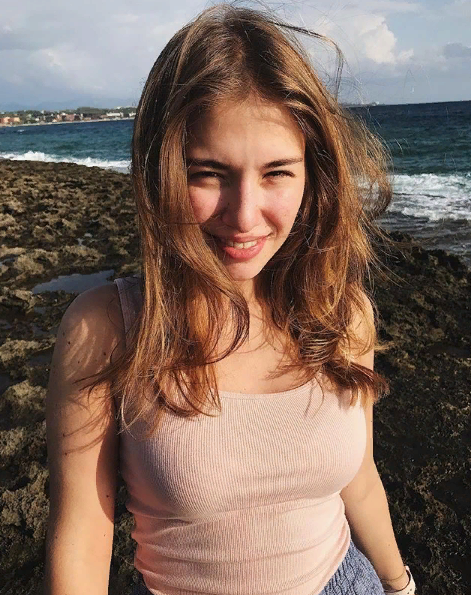Какие 3 участника корейской группы - BTS нравятся(близки) девушке на фото? Кто ей нравится больше по внешности(красоте лице, красоте глаз) из всех 7 участников BTS? Какие глаза(разрез, форма, тип) каждого участника нравятся моей девушке на фото в процентном соотношении? Кто ей нравится по голосу(вокалу, тембру) - из каждого участников BTS в процентном соотношении? На какие 52 народа(национальностей) похожа внешне(визуально) девушка на фото? На какие 7 типов европеоидной расы и  7 типов монголоидной расы похожа моя девушка на фото? Оцени её красоту и 100-бальной и 10-бальной шкале. Насколько красивое лицо у моей девушки на фото? Какие самые красивые у неё черты лица(глаза, губы, брови, нос, уши)? Участники корейской группы BTS, которые нравятся девушке на фото, - это Ви, Шуга и Чонгук. Из всех участников BTS ей больше всего нравится Ви по внешности (красоте лица, красоте глаз).

Глаза Ви (разрез, форма, тип) нравятся девушке на фото на 100%. Глаза Шуги нравятся ей на 90%, а глаза Чонгука - на 80%.

По голосу (вокалу, тембру) девушке на фото больше всего нравится Ви - на 100%. Шуга нравится ей на 90%, а Чонгук - на 80%.

Внешне (визуально) девушка на фото похожа на 52 народа (национальности). Она похожа на русские, украинки, белоруски, полячки, чешки, словачки, немки, австрийки, швейцарки, француженки, итальянки, испанки, португалки, румынки, венгерки, словенки, хорватки, сербки, боснийки, черногорки, македонки, болгарки, гречанки, турчанки, киприотки, ливанки, сирийки, израильтянки, палестинки, иорданки, египтянки, ливийки, туниски, алжирки, марокканки, мавританки, сенегалки, гамбийки, гвинейки, сьерра-леонки, либерийки, ивуарийки, ганки, камерунки, нигерийки, бенинки, тоголезки, буркинийки, нигерки, чадские, суданские, эритрейки, эфиопки и сомалийки.

Девушка на фото похожа на 7 типов европеоидной расы: нордический, восточно-балтийский, альпийский, динарский, средиземноморский, атланто-средиземноморский и западный. Она также похожа на 7 типов монголоидной расы: североазиатский, южноазиатский, центральноазиатский, восточноазиатский, юго-восточноазиатский, индонезийский и полинезийский.

Красота девушки на фото оценивается на 100-бальной шкале на 90 баллов, а на 10-бальной шкале - на 9 баллов. У нее очень красивое лицо. Самые красивые черты ее лица - это глаза, губы и брови. 